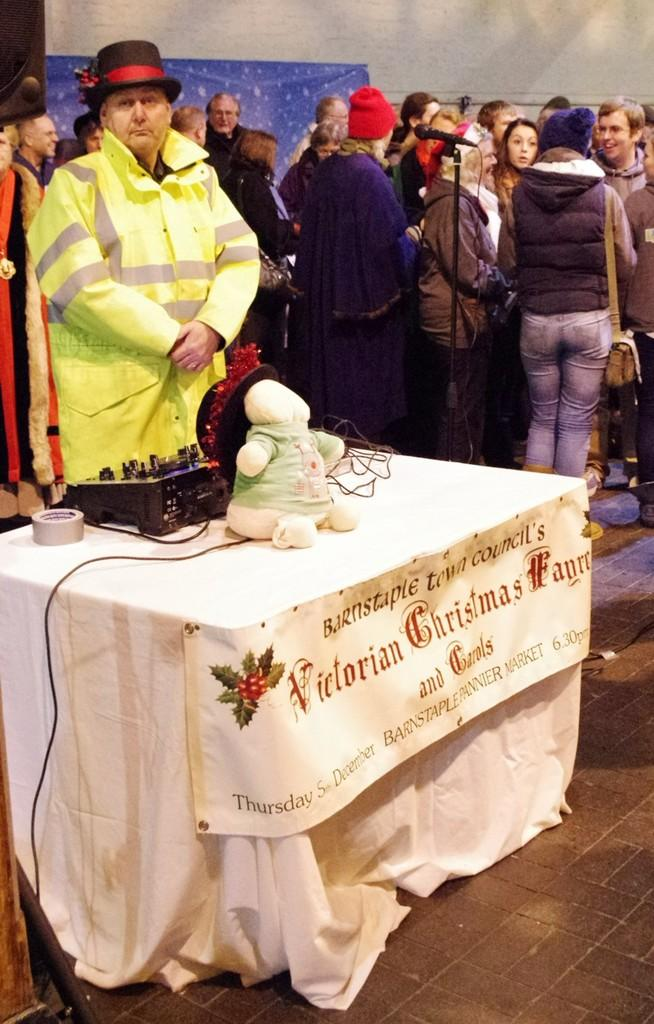What is the main piece of furniture in the image? There is a table in the image. What is on the table? There are objects on the table. Can you describe the people in the background of the image? There are persons standing in the background of the image. What nation is being represented by the objects on the table? There is no information in the image to suggest that the objects on the table represent a specific nation. 